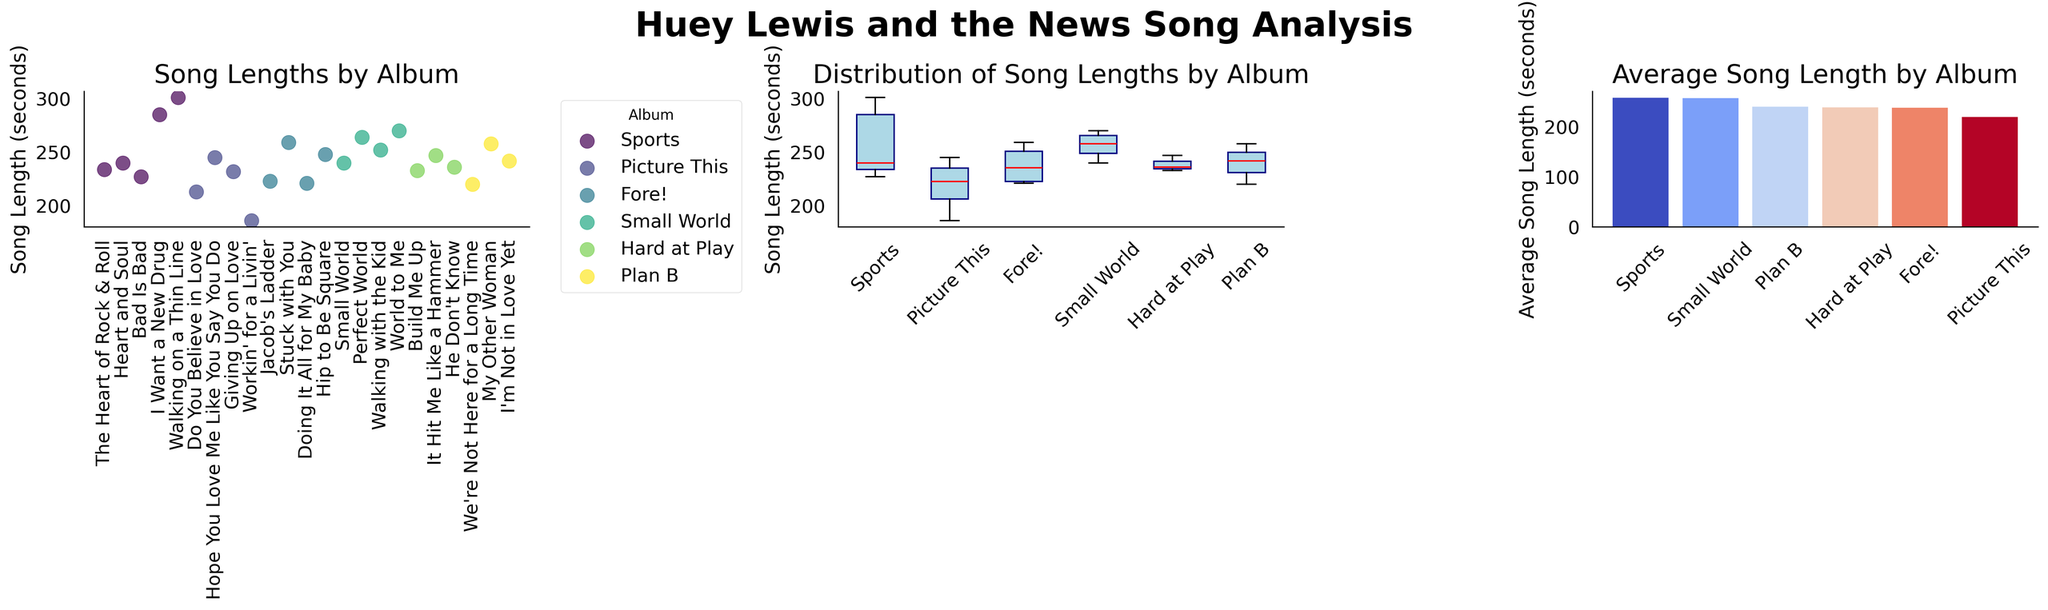What's the average song length for the album "Fore!"? The average song length for "Fore!" can be determined from the bar plot on the right. Look for the bar labeled "Fore!" and read the value.
Answer: 237.8 seconds Which album has the longest average song length? Based on the bar plot, we compare the height of each bar to see which album has the highest value.
Answer: Small World What is the median song length of the album "Sports"? The median value for "Sports" can be found in the box plot in the middle. Locate the median line inside the "Sports" box.
Answer: 240 seconds How many songs are plotted for the album "Picture This" in the scatter plot? In the scatter plot on the left, count the data points (dots) labeled for "Picture This".
Answer: 4 songs Is the average song length for "Hard at Play" longer or shorter than for "Plan B"? Compare the height of the bars for "Hard at Play" and "Plan B" in the bar plot on the right. "Hard at Play" has a shorter bar than "Plan B".
Answer: Shorter Which album has the most variability in song lengths? Look at the box plot to find the album with the widest box (largest interquartile range).
Answer: Sports Are there any songs that reach or exceed 300 seconds? In the scatter plot, check if there are any data points that reach or surpass the 300-second mark.
Answer: Yes On average, are songs from "Fore!" longer than those from "Hard at Play"? Check the average lengths in the bar plot. Compare the heights of the bars for "Fore!" and "Hard at Play".
Answer: No Which album has the most tightly grouped song lengths? In the box plot, the album with the smallest box (smallest interquartile range) indicates the most tightly grouped song lengths.
Answer: Hard at Play 